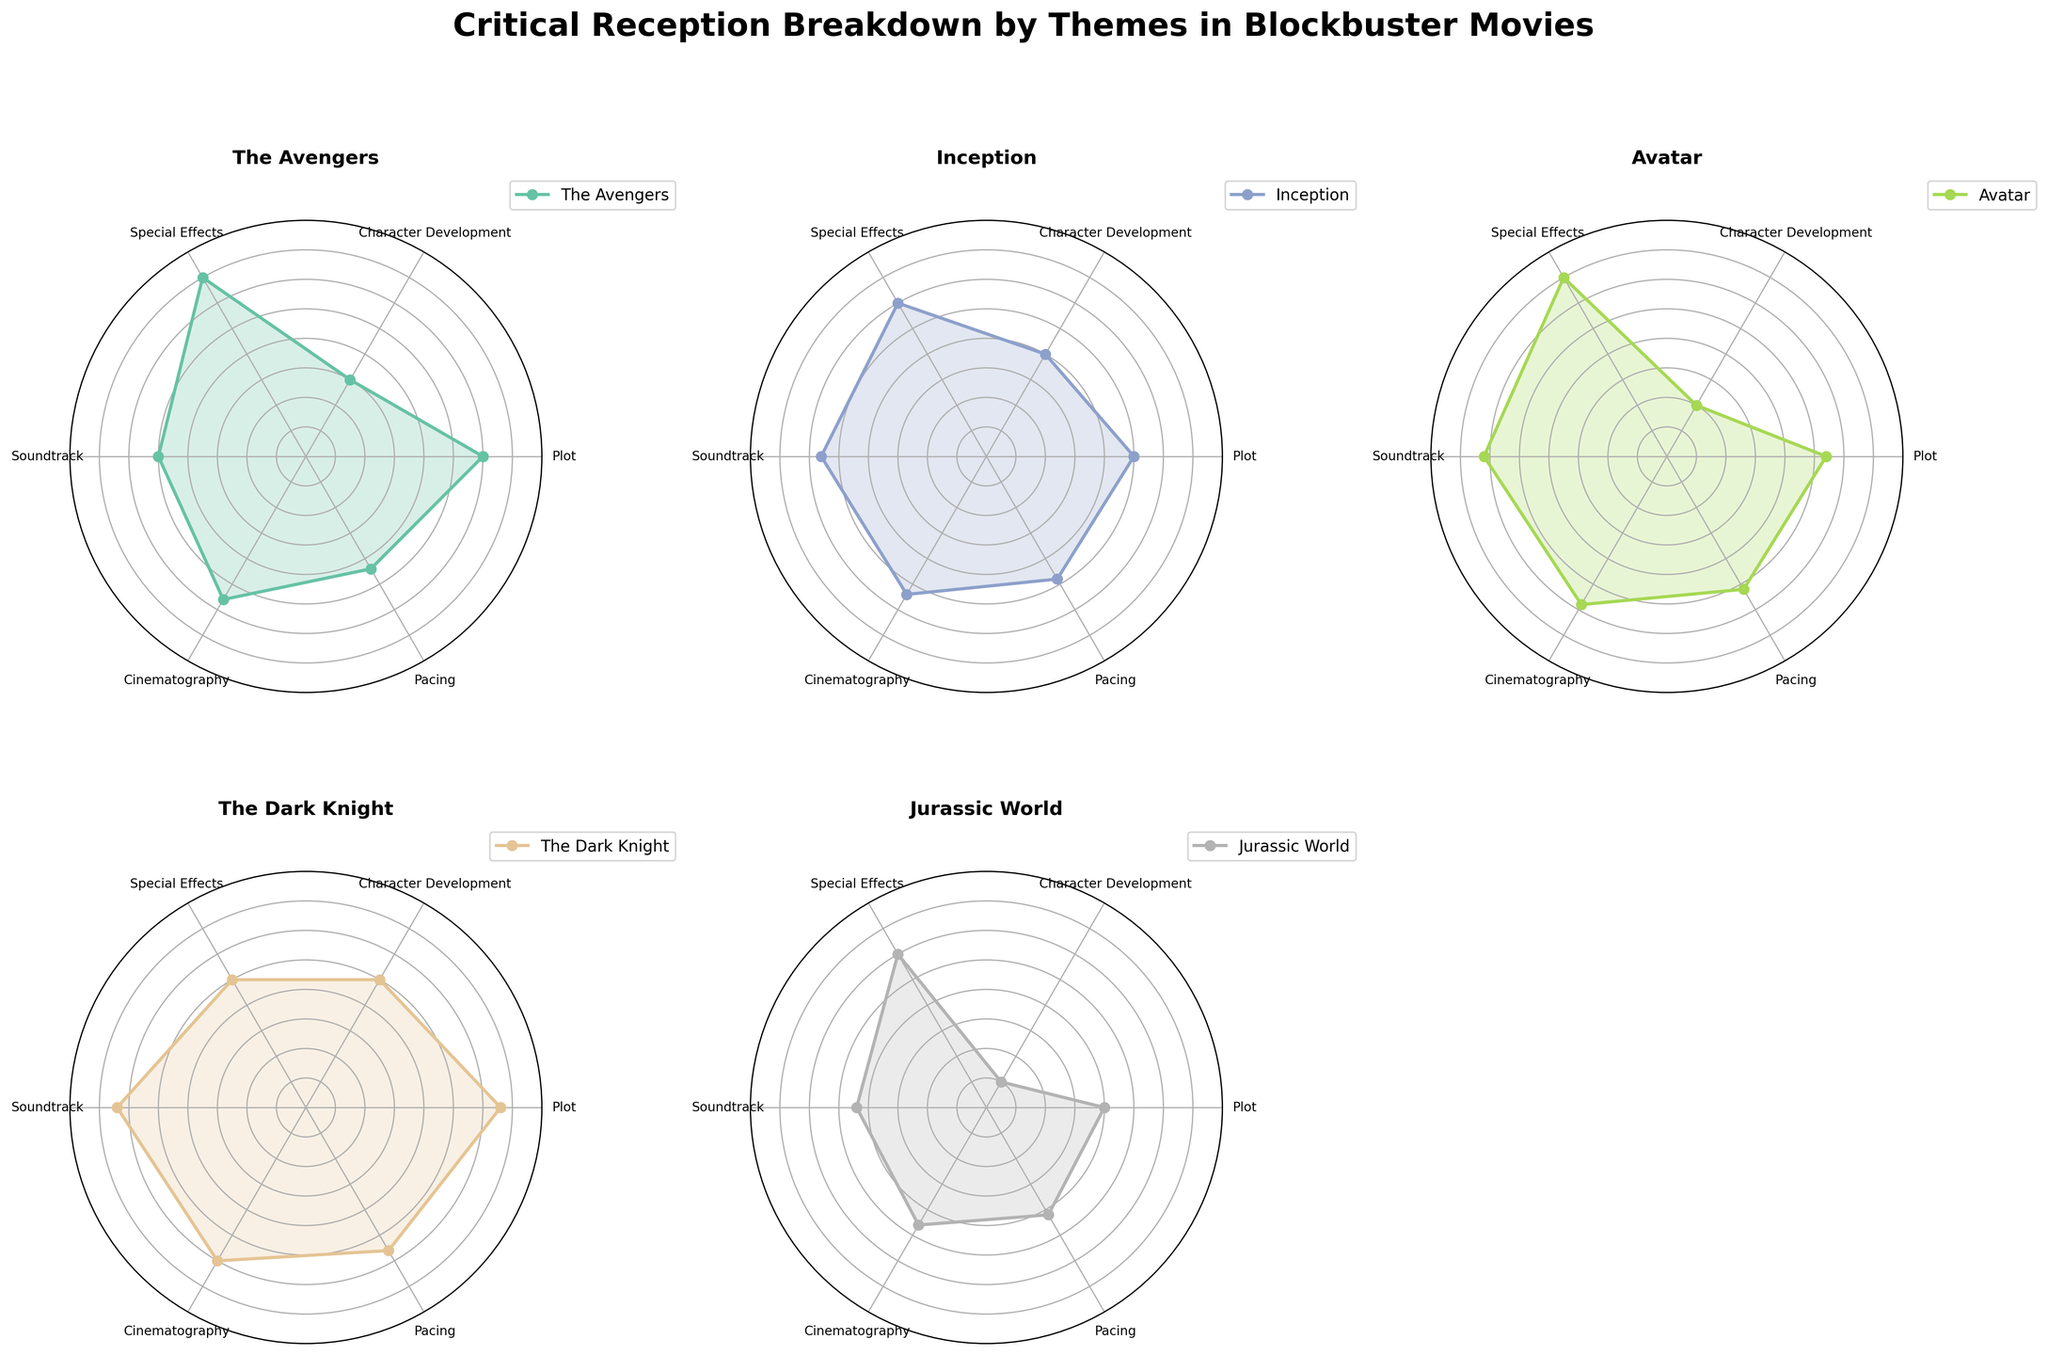What theme has the highest score for "The Avengers"? Look at the radar chart for "The Avengers" and identify the theme with the longest radius. The theme Special Effects is at 95, which is the highest.
Answer: Special Effects Which movie has the lowest score for Character Development? Check the Character Development axis for all movies. Jurassic World has the lowest score at 65.
Answer: Jurassic World What is the average score for Avatar across all themes? Sum up all the scores for Avatar (87 + 70 + 95 + 91 + 89 + 86 = 518). Divide 518 by the number of themes (6).
Answer: 86.33 How does the score for Plot in Inception compare to Plot in The Dark Knight? Locate the Plot scores for both movies. Inception has 85, and The Dark Knight has 93. The Dark Knight’s score is higher.
Answer: The Dark Knight is higher Which movie has the closest scores for Pacing and Cinematography? Check the Pacing and Cinematography scores for each movie. The Dark Knight has Pacing at 88 and Cinematography at 90, which are closest.
Answer: The Dark Knight What is the difference between the highest and lowest scores for Jurassic World? Identify the maximum score (Special Effects = 90) and the minimum score (Character Development = 65) for Jurassic World. Subtract the minimum from the maximum (90-65=25).
Answer: 25 Which theme shows the smallest variation in scores across all movies? Observe the radar charts for each theme and note the range of scores. Cinematography has scores ranging from 83 to 90, a small variation of 7.
Answer: Cinematography What is the total score for "The Dark Knight" in both Plot and Soundtrack? Add the scores for Plot (93) and Soundtrack (92) for The Dark Knight. (93 + 92 = 185)
Answer: 185 Which two movies have the most similar overall shapes in their radar charts? Visually compare the shapes of the radar charts. The Avengers and Inception have similar overall shapes and trends in their scores, especially in themes like Plot, Special Effects, and Soundtrack.
Answer: The Avengers and Inception 